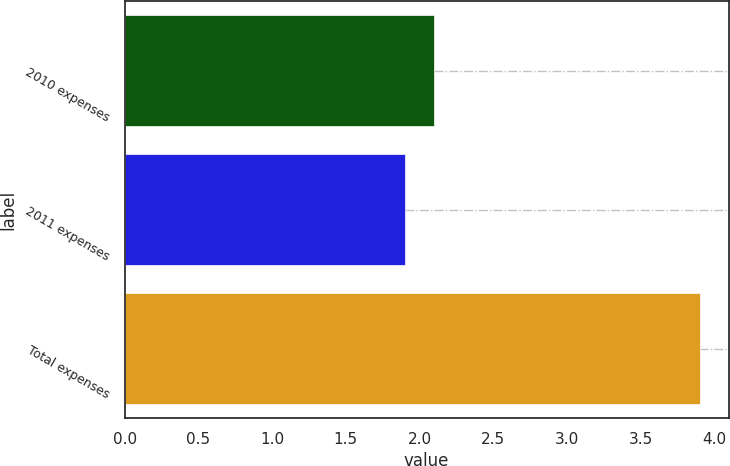<chart> <loc_0><loc_0><loc_500><loc_500><bar_chart><fcel>2010 expenses<fcel>2011 expenses<fcel>Total expenses<nl><fcel>2.1<fcel>1.9<fcel>3.9<nl></chart> 